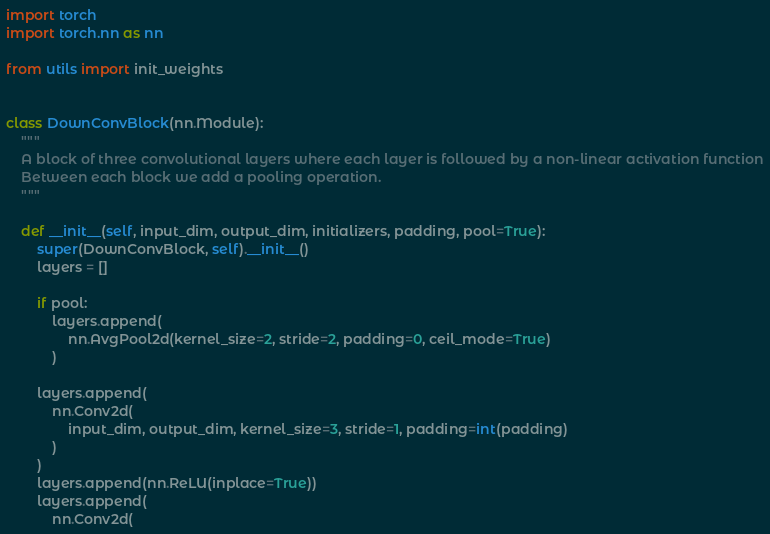<code> <loc_0><loc_0><loc_500><loc_500><_Python_>import torch
import torch.nn as nn

from utils import init_weights


class DownConvBlock(nn.Module):
    """
    A block of three convolutional layers where each layer is followed by a non-linear activation function
    Between each block we add a pooling operation.
    """

    def __init__(self, input_dim, output_dim, initializers, padding, pool=True):
        super(DownConvBlock, self).__init__()
        layers = []

        if pool:
            layers.append(
                nn.AvgPool2d(kernel_size=2, stride=2, padding=0, ceil_mode=True)
            )

        layers.append(
            nn.Conv2d(
                input_dim, output_dim, kernel_size=3, stride=1, padding=int(padding)
            )
        )
        layers.append(nn.ReLU(inplace=True))
        layers.append(
            nn.Conv2d(</code> 